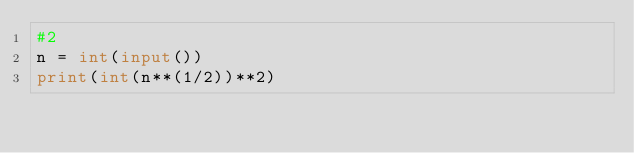<code> <loc_0><loc_0><loc_500><loc_500><_Python_>#2
n = int(input())
print(int(n**(1/2))**2)</code> 